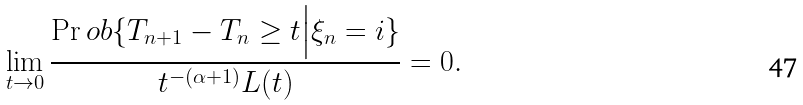Convert formula to latex. <formula><loc_0><loc_0><loc_500><loc_500>\lim _ { t \rightarrow 0 } \frac { \Pr o b \{ T _ { n + 1 } - T _ { n } \geq t \Big | \xi _ { n } = i \} } { t ^ { - ( \alpha + 1 ) } L ( t ) } = 0 .</formula> 